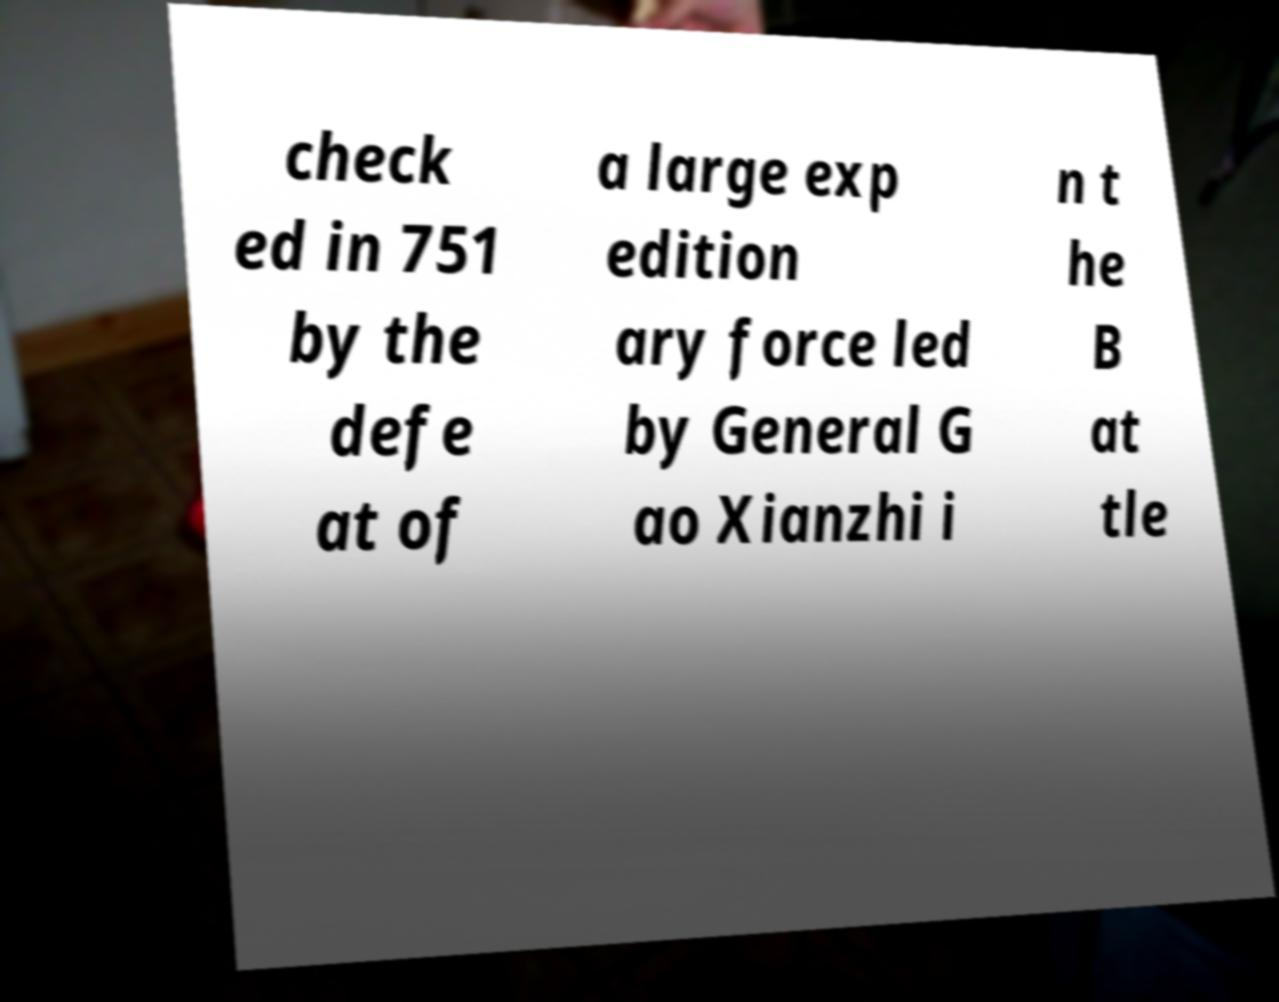For documentation purposes, I need the text within this image transcribed. Could you provide that? check ed in 751 by the defe at of a large exp edition ary force led by General G ao Xianzhi i n t he B at tle 